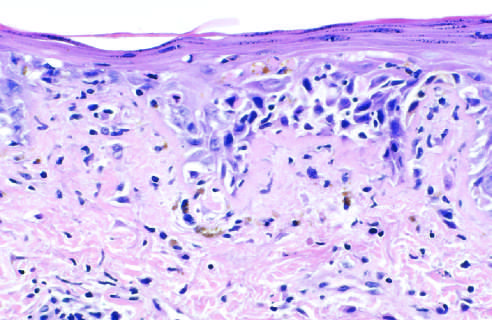does an h&e-stained section show liquefactive degeneration of the basal layer of the epidermis and edema at the dermoepidermal junction?
Answer the question using a single word or phrase. Yes 